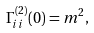Convert formula to latex. <formula><loc_0><loc_0><loc_500><loc_500>\Gamma _ { i i } ^ { ( 2 ) } ( 0 ) = m ^ { 2 } ,</formula> 